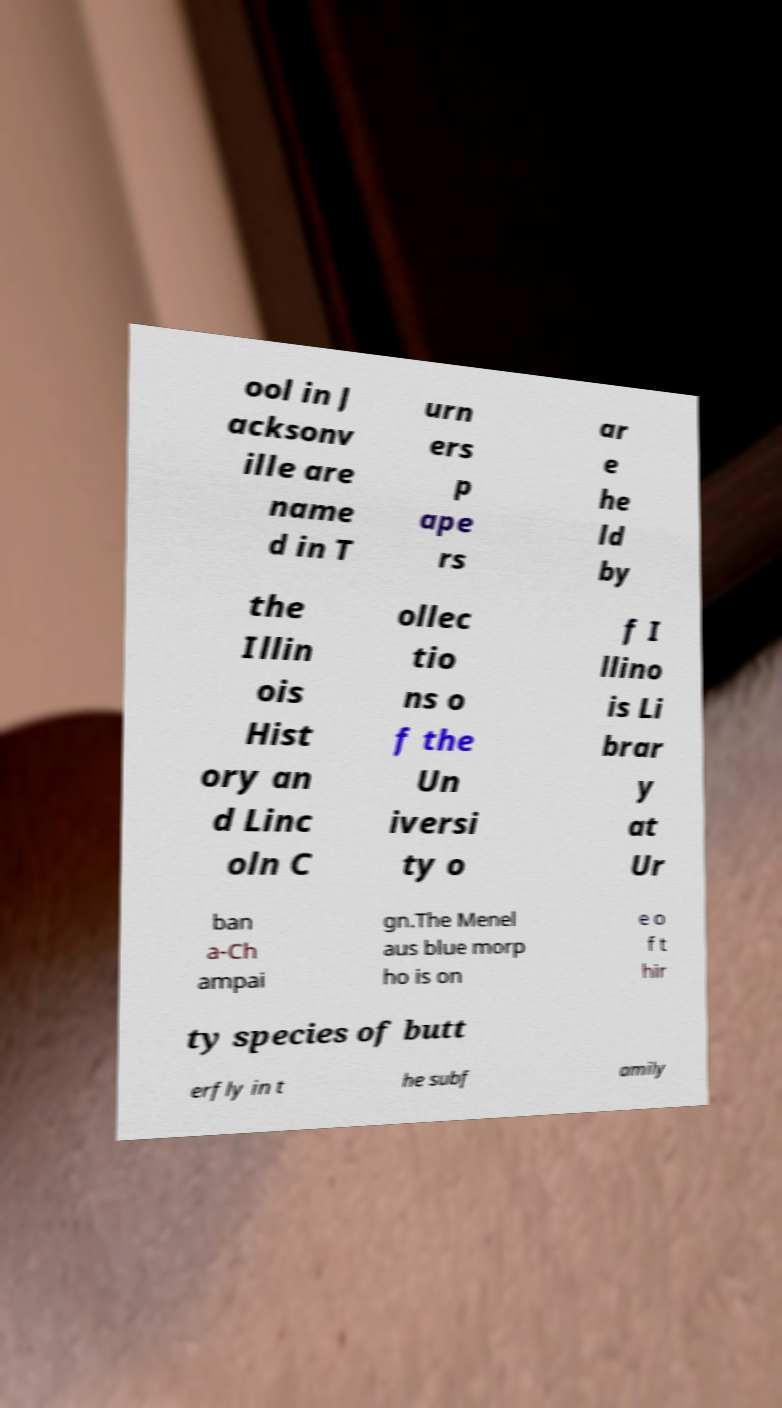Can you accurately transcribe the text from the provided image for me? ool in J acksonv ille are name d in T urn ers p ape rs ar e he ld by the Illin ois Hist ory an d Linc oln C ollec tio ns o f the Un iversi ty o f I llino is Li brar y at Ur ban a-Ch ampai gn.The Menel aus blue morp ho is on e o f t hir ty species of butt erfly in t he subf amily 